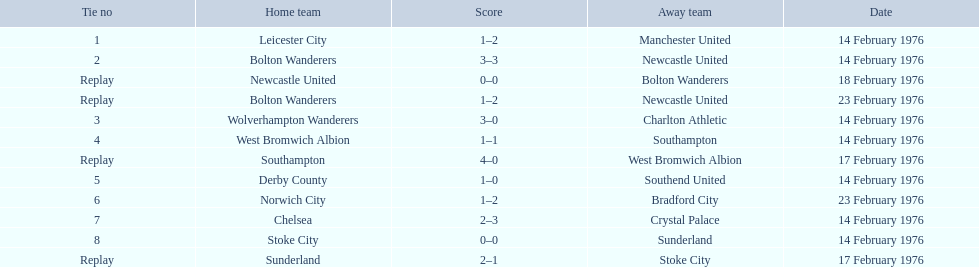Who were the participating teams? Leicester City, Manchester United, Bolton Wanderers, Newcastle United, Newcastle United, Bolton Wanderers, Bolton Wanderers, Newcastle United, Wolverhampton Wanderers, Charlton Athletic, West Bromwich Albion, Southampton, Southampton, West Bromwich Albion, Derby County, Southend United, Norwich City, Bradford City, Chelsea, Crystal Palace, Stoke City, Sunderland, Sunderland, Stoke City. Which one of them won? Manchester United, Newcastle United, Wolverhampton Wanderers, Southampton, Derby County, Bradford City, Crystal Palace, Sunderland. What was the winning score for manchester united? 1–2. What was the winning score for wolverhampton wanderers? 3–0. Which of these two teams had a higher winning score? Wolverhampton Wanderers. Could you parse the entire table? {'header': ['Tie no', 'Home team', 'Score', 'Away team', 'Date'], 'rows': [['1', 'Leicester City', '1–2', 'Manchester United', '14 February 1976'], ['2', 'Bolton Wanderers', '3–3', 'Newcastle United', '14 February 1976'], ['Replay', 'Newcastle United', '0–0', 'Bolton Wanderers', '18 February 1976'], ['Replay', 'Bolton Wanderers', '1–2', 'Newcastle United', '23 February 1976'], ['3', 'Wolverhampton Wanderers', '3–0', 'Charlton Athletic', '14 February 1976'], ['4', 'West Bromwich Albion', '1–1', 'Southampton', '14 February 1976'], ['Replay', 'Southampton', '4–0', 'West Bromwich Albion', '17 February 1976'], ['5', 'Derby County', '1–0', 'Southend United', '14 February 1976'], ['6', 'Norwich City', '1–2', 'Bradford City', '23 February 1976'], ['7', 'Chelsea', '2–3', 'Crystal Palace', '14 February 1976'], ['8', 'Stoke City', '0–0', 'Sunderland', '14 February 1976'], ['Replay', 'Sunderland', '2–1', 'Stoke City', '17 February 1976']]} 